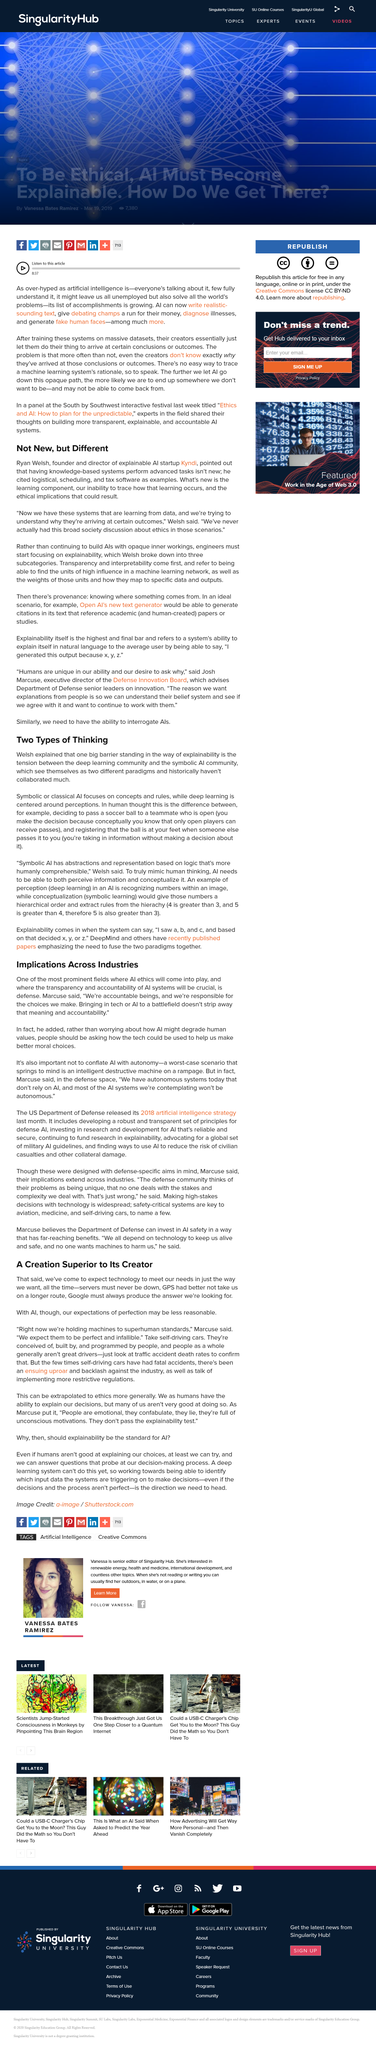Highlight a few significant elements in this photo. The person who stated in the article, 'We're accountable human beings,' is named Marcuse. In his explanation of symbolic AI in human thought, Welsh uses the example of a person passing a football to a teammate, which demonstrates how the rules of the game are used similarly to how symbolic AI processes and makes decisions. Ryan is the founder and director of Kyndi. Welsh refers to the "deep learning community" and the "symbolic AI community" as the two types of thinking communities. According to the article, systems learn from data. 